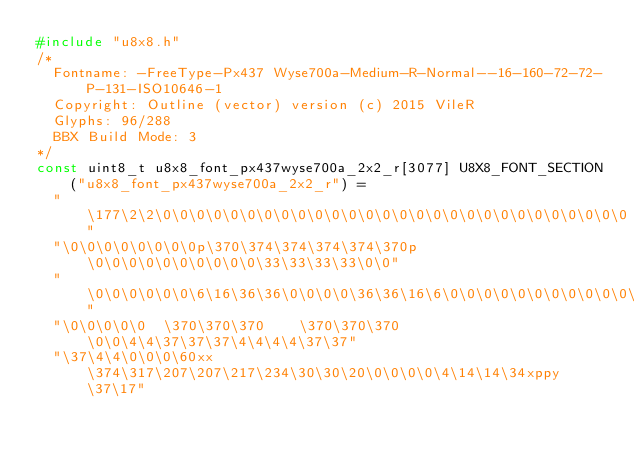<code> <loc_0><loc_0><loc_500><loc_500><_C_>#include "u8x8.h"
/*
  Fontname: -FreeType-Px437 Wyse700a-Medium-R-Normal--16-160-72-72-P-131-ISO10646-1
  Copyright: Outline (vector) version (c) 2015 VileR
  Glyphs: 96/288
  BBX Build Mode: 3
*/
const uint8_t u8x8_font_px437wyse700a_2x2_r[3077] U8X8_FONT_SECTION("u8x8_font_px437wyse700a_2x2_r") = 
  " \177\2\2\0\0\0\0\0\0\0\0\0\0\0\0\0\0\0\0\0\0\0\0\0\0\0\0\0\0\0\0"
  "\0\0\0\0\0\0\0\0p\370\374\374\374\374\370p\0\0\0\0\0\0\0\0\0\0\33\33\33\33\0\0"
  "\0\0\0\0\0\0\6\16\36\36\0\0\0\0\36\36\16\6\0\0\0\0\0\0\0\0\0\0\0\0\0\0"
  "\0\0\0\0\0  \370\370\370    \370\370\370  \0\0\4\4\37\37\37\4\4\4\4\37\37"
  "\37\4\4\0\0\0\60xx\374\317\207\207\217\234\30\30\20\0\0\0\0\4\14\14\34xppy\37\17"</code> 